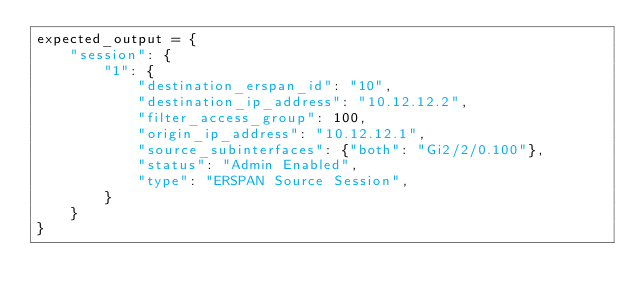Convert code to text. <code><loc_0><loc_0><loc_500><loc_500><_Python_>expected_output = {
    "session": {
        "1": {
            "destination_erspan_id": "10",
            "destination_ip_address": "10.12.12.2",
            "filter_access_group": 100,
            "origin_ip_address": "10.12.12.1",
            "source_subinterfaces": {"both": "Gi2/2/0.100"},
            "status": "Admin Enabled",
            "type": "ERSPAN Source Session",
        }
    }
}
</code> 